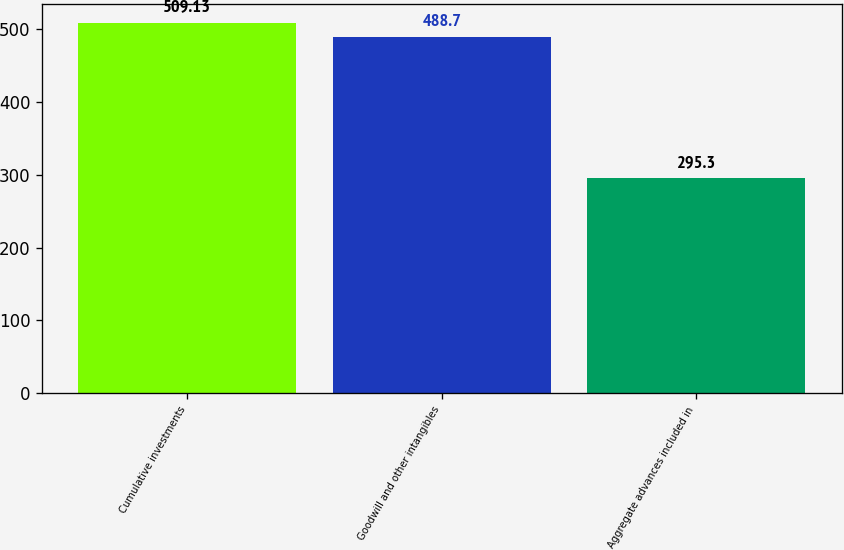Convert chart. <chart><loc_0><loc_0><loc_500><loc_500><bar_chart><fcel>Cumulative investments<fcel>Goodwill and other intangibles<fcel>Aggregate advances included in<nl><fcel>509.13<fcel>488.7<fcel>295.3<nl></chart> 